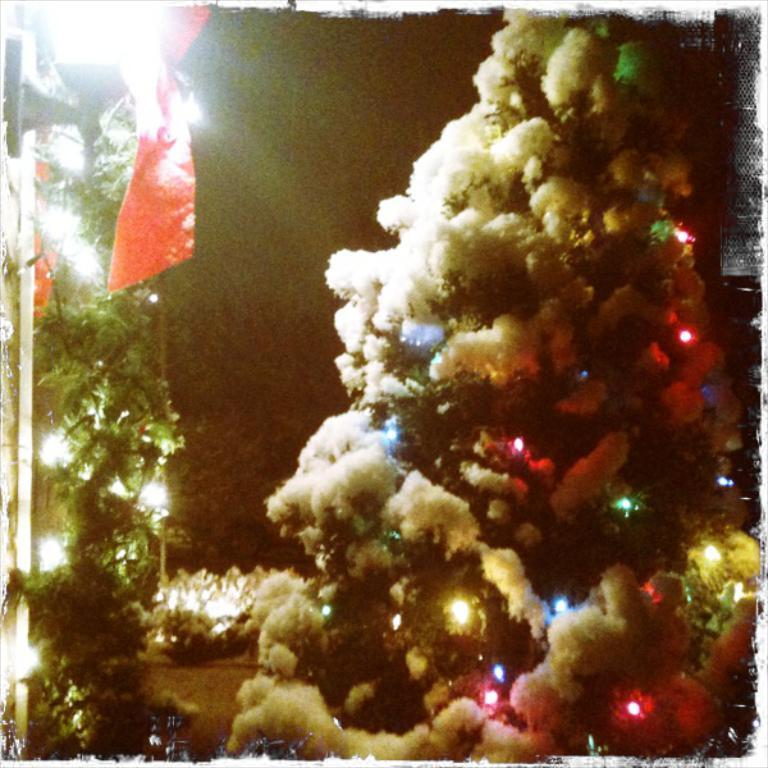What type of tree is in the image? There is an xmas tree in the image. What feature does the xmas tree have? The xmas tree has lights. What weather condition is depicted in the image? There is snow visible in the image. What appliance is making a voice in the image? There is no appliance making a voice in the image. What type of branch is visible in the image? There is no specific branch mentioned or visible in the image. 